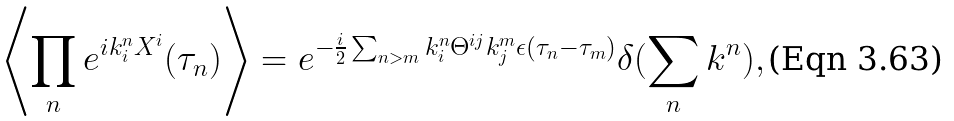<formula> <loc_0><loc_0><loc_500><loc_500>\left \langle \prod _ { n } e ^ { i k ^ { n } _ { i } X ^ { i } } ( \tau _ { n } ) \right \rangle = e ^ { - \frac { i } { 2 } \sum _ { n > m } k ^ { n } _ { i } \Theta ^ { i j } k ^ { m } _ { j } \epsilon ( \tau _ { n } - \tau _ { m } ) } \delta ( \sum _ { n } k ^ { n } ) ,</formula> 